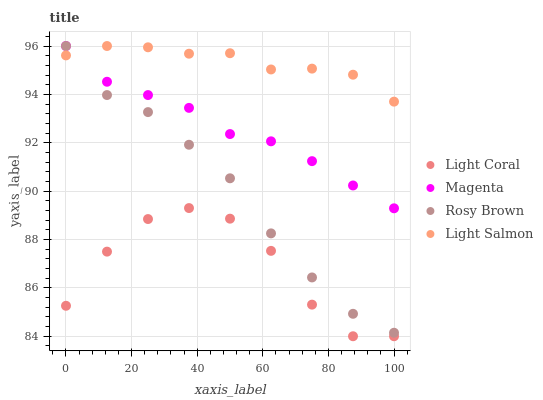Does Light Coral have the minimum area under the curve?
Answer yes or no. Yes. Does Light Salmon have the maximum area under the curve?
Answer yes or no. Yes. Does Magenta have the minimum area under the curve?
Answer yes or no. No. Does Magenta have the maximum area under the curve?
Answer yes or no. No. Is Magenta the smoothest?
Answer yes or no. Yes. Is Light Coral the roughest?
Answer yes or no. Yes. Is Rosy Brown the smoothest?
Answer yes or no. No. Is Rosy Brown the roughest?
Answer yes or no. No. Does Light Coral have the lowest value?
Answer yes or no. Yes. Does Magenta have the lowest value?
Answer yes or no. No. Does Light Salmon have the highest value?
Answer yes or no. Yes. Is Light Coral less than Rosy Brown?
Answer yes or no. Yes. Is Magenta greater than Light Coral?
Answer yes or no. Yes. Does Light Salmon intersect Rosy Brown?
Answer yes or no. Yes. Is Light Salmon less than Rosy Brown?
Answer yes or no. No. Is Light Salmon greater than Rosy Brown?
Answer yes or no. No. Does Light Coral intersect Rosy Brown?
Answer yes or no. No. 